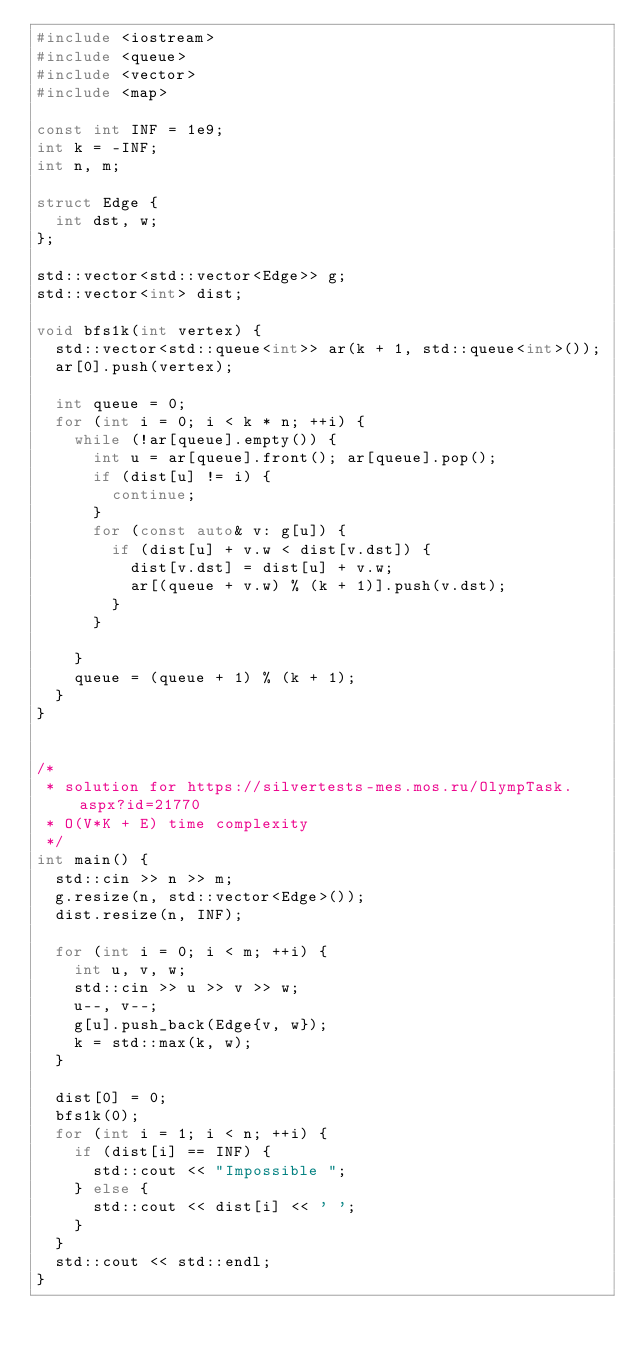Convert code to text. <code><loc_0><loc_0><loc_500><loc_500><_C++_>#include <iostream>
#include <queue>
#include <vector>
#include <map>

const int INF = 1e9;
int k = -INF;
int n, m;

struct Edge {
  int dst, w;
};

std::vector<std::vector<Edge>> g;
std::vector<int> dist;

void bfs1k(int vertex) {
  std::vector<std::queue<int>> ar(k + 1, std::queue<int>());
  ar[0].push(vertex);

  int queue = 0;
  for (int i = 0; i < k * n; ++i) {
    while (!ar[queue].empty()) {
      int u = ar[queue].front(); ar[queue].pop();
      if (dist[u] != i) {
        continue;
      }
      for (const auto& v: g[u]) {
        if (dist[u] + v.w < dist[v.dst]) {
          dist[v.dst] = dist[u] + v.w;
          ar[(queue + v.w) % (k + 1)].push(v.dst);
        }
      }

    }
    queue = (queue + 1) % (k + 1);
  }
}


/*
 * solution for https://silvertests-mes.mos.ru/OlympTask.aspx?id=21770
 * O(V*K + E) time complexity
 */
int main() {
  std::cin >> n >> m;
  g.resize(n, std::vector<Edge>());
  dist.resize(n, INF);

  for (int i = 0; i < m; ++i) {
    int u, v, w;
    std::cin >> u >> v >> w;
    u--, v--;
    g[u].push_back(Edge{v, w});
    k = std::max(k, w);
  }

  dist[0] = 0;
  bfs1k(0);
  for (int i = 1; i < n; ++i) {
    if (dist[i] == INF) {
      std::cout << "Impossible ";
    } else {
      std::cout << dist[i] << ' ';
    }
  }
  std::cout << std::endl;
}</code> 